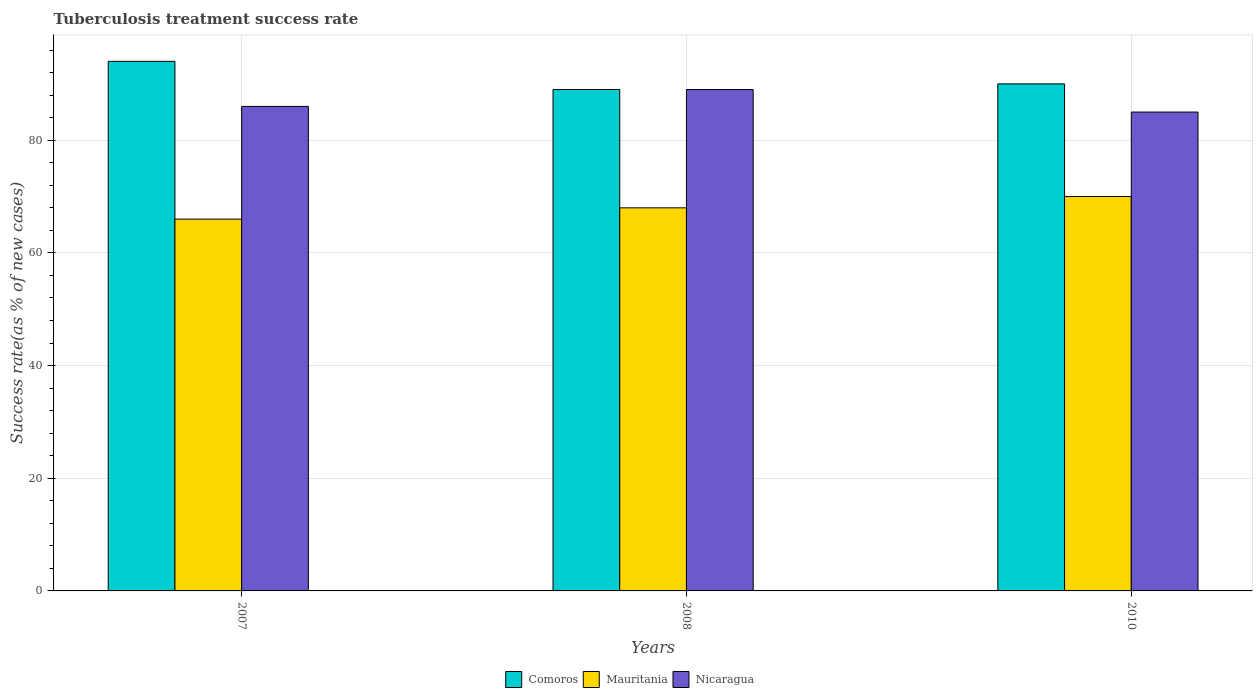How many different coloured bars are there?
Ensure brevity in your answer.  3. Are the number of bars per tick equal to the number of legend labels?
Keep it short and to the point. Yes. How many bars are there on the 3rd tick from the left?
Ensure brevity in your answer.  3. What is the tuberculosis treatment success rate in Nicaragua in 2007?
Provide a short and direct response. 86. Across all years, what is the maximum tuberculosis treatment success rate in Comoros?
Provide a short and direct response. 94. Across all years, what is the minimum tuberculosis treatment success rate in Nicaragua?
Your response must be concise. 85. What is the total tuberculosis treatment success rate in Mauritania in the graph?
Provide a succinct answer. 204. What is the difference between the tuberculosis treatment success rate in Nicaragua in 2007 and that in 2008?
Give a very brief answer. -3. What is the difference between the tuberculosis treatment success rate in Mauritania in 2007 and the tuberculosis treatment success rate in Nicaragua in 2010?
Your response must be concise. -19. What is the average tuberculosis treatment success rate in Nicaragua per year?
Your response must be concise. 86.67. In how many years, is the tuberculosis treatment success rate in Mauritania greater than 44 %?
Offer a very short reply. 3. What is the ratio of the tuberculosis treatment success rate in Comoros in 2007 to that in 2008?
Offer a very short reply. 1.06. Is the tuberculosis treatment success rate in Mauritania in 2007 less than that in 2008?
Provide a succinct answer. Yes. Is the difference between the tuberculosis treatment success rate in Mauritania in 2007 and 2008 greater than the difference between the tuberculosis treatment success rate in Comoros in 2007 and 2008?
Your answer should be very brief. No. What is the difference between the highest and the lowest tuberculosis treatment success rate in Nicaragua?
Your response must be concise. 4. Is the sum of the tuberculosis treatment success rate in Comoros in 2007 and 2008 greater than the maximum tuberculosis treatment success rate in Nicaragua across all years?
Keep it short and to the point. Yes. What does the 1st bar from the left in 2010 represents?
Provide a succinct answer. Comoros. What does the 3rd bar from the right in 2008 represents?
Make the answer very short. Comoros. What is the difference between two consecutive major ticks on the Y-axis?
Make the answer very short. 20. Does the graph contain any zero values?
Ensure brevity in your answer.  No. Does the graph contain grids?
Your response must be concise. Yes. How many legend labels are there?
Ensure brevity in your answer.  3. What is the title of the graph?
Provide a succinct answer. Tuberculosis treatment success rate. Does "Barbados" appear as one of the legend labels in the graph?
Make the answer very short. No. What is the label or title of the Y-axis?
Your response must be concise. Success rate(as % of new cases). What is the Success rate(as % of new cases) of Comoros in 2007?
Provide a short and direct response. 94. What is the Success rate(as % of new cases) of Mauritania in 2007?
Ensure brevity in your answer.  66. What is the Success rate(as % of new cases) in Comoros in 2008?
Ensure brevity in your answer.  89. What is the Success rate(as % of new cases) of Nicaragua in 2008?
Provide a short and direct response. 89. What is the Success rate(as % of new cases) of Nicaragua in 2010?
Ensure brevity in your answer.  85. Across all years, what is the maximum Success rate(as % of new cases) of Comoros?
Offer a terse response. 94. Across all years, what is the maximum Success rate(as % of new cases) of Mauritania?
Provide a succinct answer. 70. Across all years, what is the maximum Success rate(as % of new cases) of Nicaragua?
Your answer should be very brief. 89. Across all years, what is the minimum Success rate(as % of new cases) in Comoros?
Make the answer very short. 89. What is the total Success rate(as % of new cases) in Comoros in the graph?
Offer a terse response. 273. What is the total Success rate(as % of new cases) of Mauritania in the graph?
Keep it short and to the point. 204. What is the total Success rate(as % of new cases) in Nicaragua in the graph?
Keep it short and to the point. 260. What is the difference between the Success rate(as % of new cases) of Comoros in 2007 and that in 2008?
Your answer should be compact. 5. What is the difference between the Success rate(as % of new cases) in Comoros in 2007 and the Success rate(as % of new cases) in Mauritania in 2010?
Provide a short and direct response. 24. What is the difference between the Success rate(as % of new cases) in Comoros in 2007 and the Success rate(as % of new cases) in Nicaragua in 2010?
Offer a terse response. 9. What is the difference between the Success rate(as % of new cases) of Comoros in 2008 and the Success rate(as % of new cases) of Mauritania in 2010?
Make the answer very short. 19. What is the difference between the Success rate(as % of new cases) of Comoros in 2008 and the Success rate(as % of new cases) of Nicaragua in 2010?
Provide a short and direct response. 4. What is the average Success rate(as % of new cases) in Comoros per year?
Give a very brief answer. 91. What is the average Success rate(as % of new cases) of Mauritania per year?
Your response must be concise. 68. What is the average Success rate(as % of new cases) in Nicaragua per year?
Offer a very short reply. 86.67. In the year 2007, what is the difference between the Success rate(as % of new cases) in Comoros and Success rate(as % of new cases) in Mauritania?
Your answer should be compact. 28. In the year 2008, what is the difference between the Success rate(as % of new cases) of Comoros and Success rate(as % of new cases) of Nicaragua?
Give a very brief answer. 0. In the year 2010, what is the difference between the Success rate(as % of new cases) of Comoros and Success rate(as % of new cases) of Mauritania?
Provide a succinct answer. 20. What is the ratio of the Success rate(as % of new cases) of Comoros in 2007 to that in 2008?
Offer a very short reply. 1.06. What is the ratio of the Success rate(as % of new cases) in Mauritania in 2007 to that in 2008?
Provide a short and direct response. 0.97. What is the ratio of the Success rate(as % of new cases) of Nicaragua in 2007 to that in 2008?
Offer a terse response. 0.97. What is the ratio of the Success rate(as % of new cases) of Comoros in 2007 to that in 2010?
Ensure brevity in your answer.  1.04. What is the ratio of the Success rate(as % of new cases) in Mauritania in 2007 to that in 2010?
Keep it short and to the point. 0.94. What is the ratio of the Success rate(as % of new cases) in Nicaragua in 2007 to that in 2010?
Provide a succinct answer. 1.01. What is the ratio of the Success rate(as % of new cases) in Comoros in 2008 to that in 2010?
Provide a succinct answer. 0.99. What is the ratio of the Success rate(as % of new cases) in Mauritania in 2008 to that in 2010?
Your response must be concise. 0.97. What is the ratio of the Success rate(as % of new cases) of Nicaragua in 2008 to that in 2010?
Offer a very short reply. 1.05. What is the difference between the highest and the second highest Success rate(as % of new cases) of Mauritania?
Your answer should be very brief. 2. What is the difference between the highest and the second highest Success rate(as % of new cases) in Nicaragua?
Your response must be concise. 3. What is the difference between the highest and the lowest Success rate(as % of new cases) of Comoros?
Provide a short and direct response. 5. What is the difference between the highest and the lowest Success rate(as % of new cases) of Mauritania?
Make the answer very short. 4. 